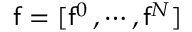<formula> <loc_0><loc_0><loc_500><loc_500>f = [ f ^ { 0 } \, , \cdots , f ^ { N } ]</formula> 